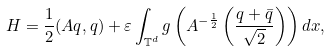Convert formula to latex. <formula><loc_0><loc_0><loc_500><loc_500>H = \frac { 1 } { 2 } ( A q , q ) + \varepsilon \int _ { \mathbb { T } ^ { d } } g \left ( A ^ { - \frac { 1 } { 2 } } \left ( \frac { q + \bar { q } } { \sqrt { 2 } } \right ) \right ) d x ,</formula> 